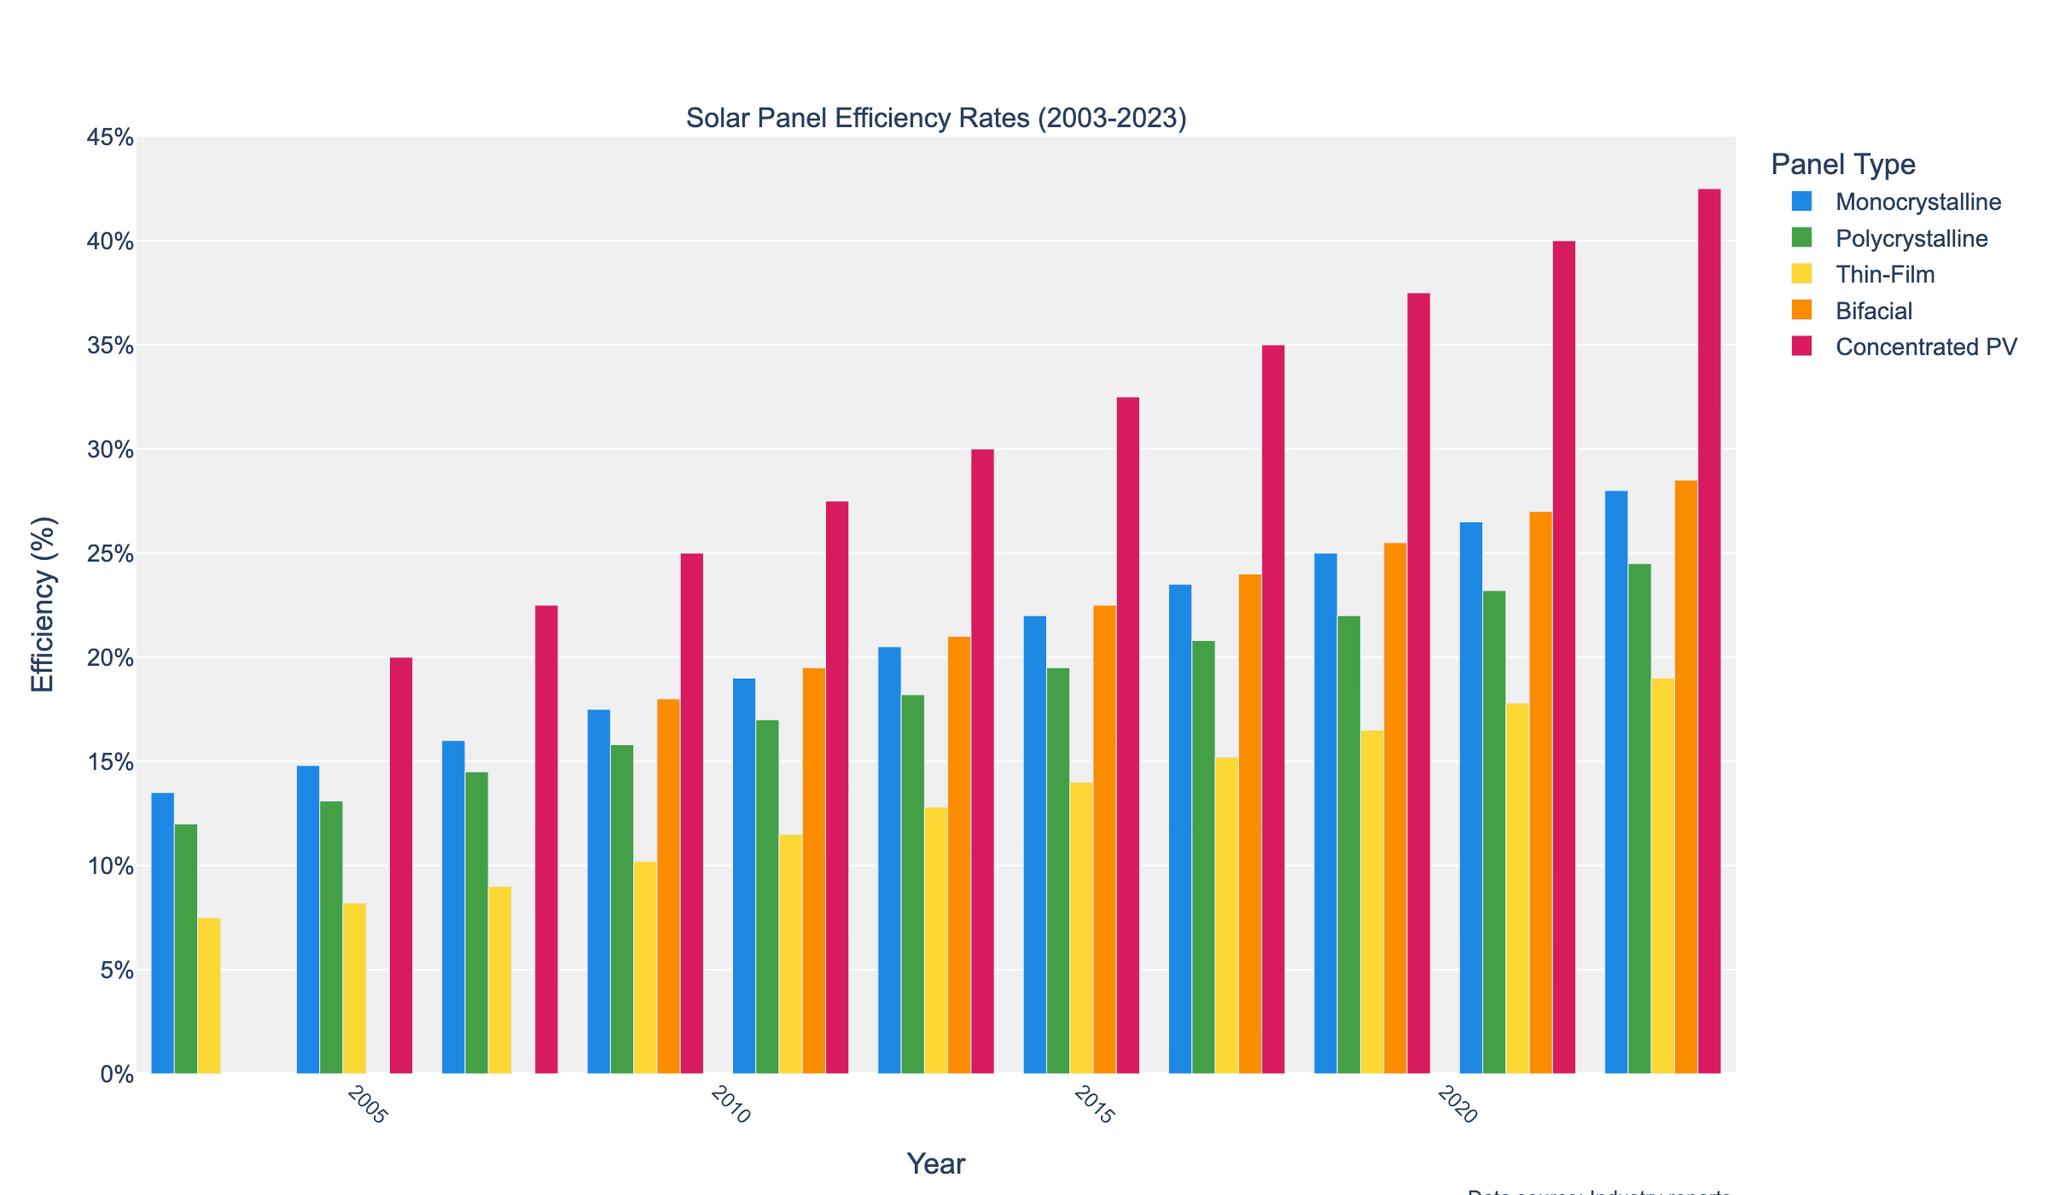What's the efficiency rate of Monocrystalline panels in 2013? Locate the year 2013 on the x-axis and find the height of the bar corresponding to Monocrystalline panels (blue bar). The value is given as 20.5%.
Answer: 20.5% Which solar panel type had the highest efficiency rate in 2005? On the x-axis, find the year 2005 and compare the heights of the bars for each panel type. Concentrated PV (red bar) has the highest efficiency rate at 20.0%.
Answer: Concentrated PV Between 2009 and 2023, how many solar panel types surpassed 20% efficiency? Check the efficiency values for all types between 2009 and 2023. Monocrystalline, Bifacial, and Concentrated PV surpassed 20% within this period.
Answer: Three Was the efficiency of Polycrystalline panels ever greater than that of Thin-Film panels? Compare the heights of the green (Polycrystalline) and yellow (Thin-Film) bars across the years. Polycrystalline panels have consistently higher efficiency than Thin-Film panels in all years.
Answer: Yes In which year did Bifacial panels reach an efficiency of 27.0%? Locate the blue-orange striped bars representing Bifacial panels and find the one with a height marking 27.0%. The year is 2021.
Answer: 2021 What is the increase in efficiency of Monocrystalline panels from 2003 to 2023? Subtract the 2003 efficiency rate of Monocrystalline panels (13.5%) from the 2023 rate (28.0%). The increase is 28.0% - 13.5% = 14.5%.
Answer: 14.5% Which year exhibited the smallest difference in efficiency between Monocrystalline and Polycrystalline panels? Calculate the yearly differences between Monocrystalline and Polycrystalline efficiencies, and find the minimum difference, which is in 2003 with a difference of 1.5% (13.5% - 12.0%).
Answer: 2003 How much more efficient is Concentrated PV compared to Thin-Film panels in 2007? Compare the heights of the red bar (Concentrated PV, 22.5%) and the yellow bar (Thin-Film, 9.0%) in 2007. The difference is 22.5% - 9.0% = 13.5%.
Answer: 13.5% Which panel type had the fastest increase in efficiency from 2005 to 2023? Calculate the efficiency increase for each panel type from 2005 to 2023. Concentrated PV increased by 42.5% - 20% = 22.5%, surpassing other panel types.
Answer: Concentrated PV 